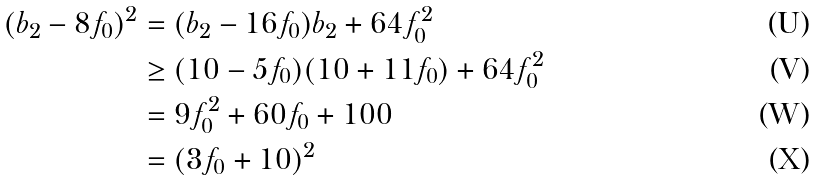<formula> <loc_0><loc_0><loc_500><loc_500>( b _ { 2 } - 8 f _ { 0 } ) ^ { 2 } & = ( b _ { 2 } - 1 6 f _ { 0 } ) b _ { 2 } + 6 4 f _ { 0 } ^ { 2 } \\ & \geq ( 1 0 - 5 f _ { 0 } ) ( 1 0 + 1 1 f _ { 0 } ) + 6 4 f _ { 0 } ^ { 2 } \\ & = 9 f _ { 0 } ^ { 2 } + 6 0 f _ { 0 } + 1 0 0 \\ & = ( 3 f _ { 0 } + 1 0 ) ^ { 2 }</formula> 